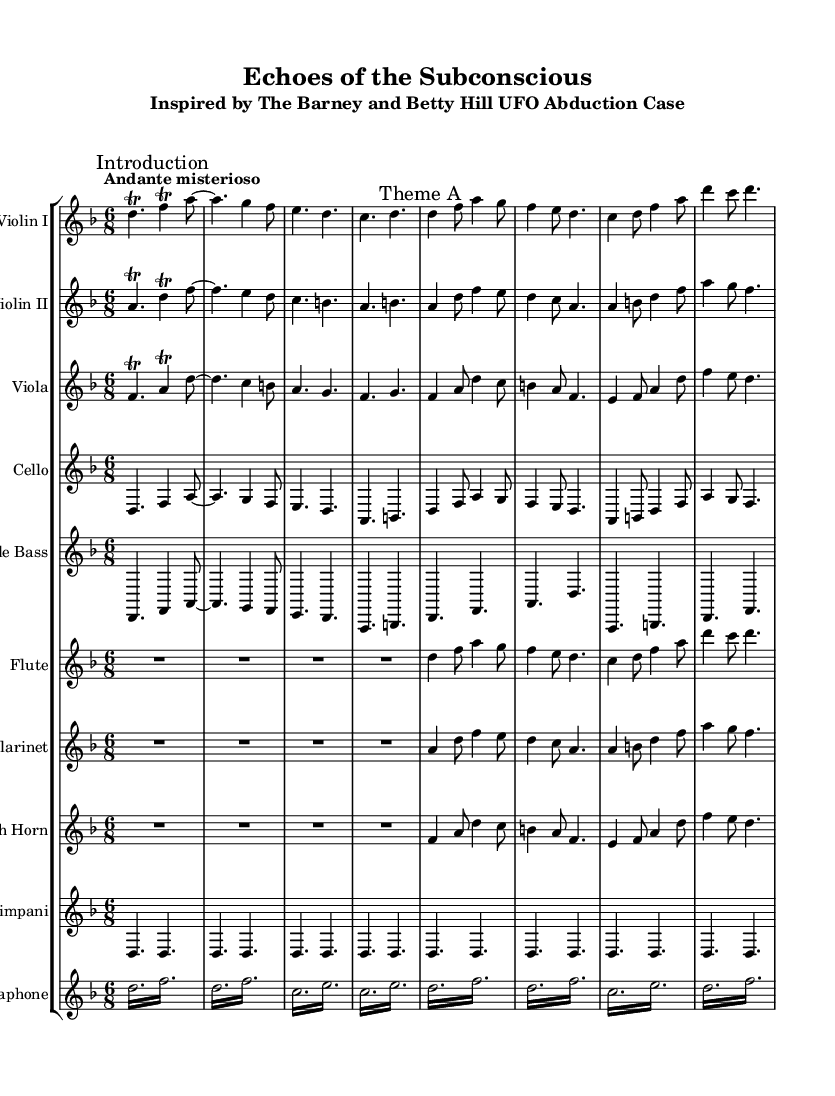What is the key signature of this music? The key signature is indicated at the beginning of the score, showing two flats, which corresponds to D minor.
Answer: D minor What is the time signature of this music? The time signature appears at the beginning of the score, indicated as 6/8, which means there are six eighth-note beats per measure.
Answer: 6/8 What is the tempo marking for this piece? The tempo marking is provided as "Andante misterioso," suggesting a moderate speed with a mysterious character.
Answer: Andante misterioso How many instruments are present in this orchestral composition? The score includes a total of ten parts: two violins, viola, cello, double bass, flute, clarinet, French horn, timpani, and vibraphone.
Answer: Ten Which melodic theme is introduced first in the score? The first melodic theme is introduced in "Violin I" marked as "Theme A," where the notes start with a trill on D.
Answer: Theme A What recurring technique is used in the vibraphone part? The vibraphone part employs a tremolo technique, where notes are rapidly alternated to create a shimmering effect.
Answer: Tremolo What psychological case study inspires this orchestral composition? The title of the composition specifically mentions that it is inspired by “The Barney and Betty Hill UFO Abduction Case,” which relates to supernatural beliefs.
Answer: The Barney and Betty Hill UFO Abduction Case 